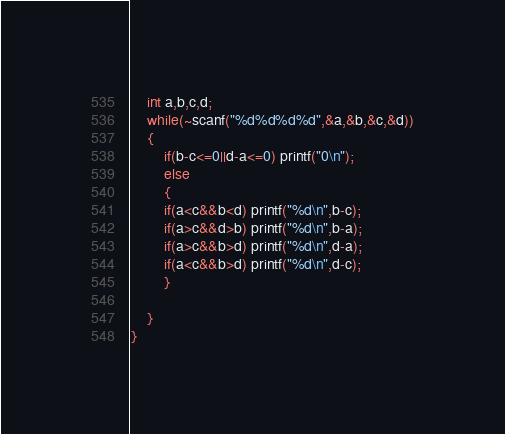<code> <loc_0><loc_0><loc_500><loc_500><_OCaml_>	int a,b,c,d;
	while(~scanf("%d%d%d%d",&a,&b,&c,&d))
	{
		if(b-c<=0||d-a<=0) printf("0\n");
		else
		{
		if(a<c&&b<d) printf("%d\n",b-c);
		if(a>c&&d>b) printf("%d\n",b-a);
		if(a>c&&b>d) printf("%d\n",d-a);
	    if(a<c&&b>d) printf("%d\n",d-c);
		}
	
	}
}</code> 